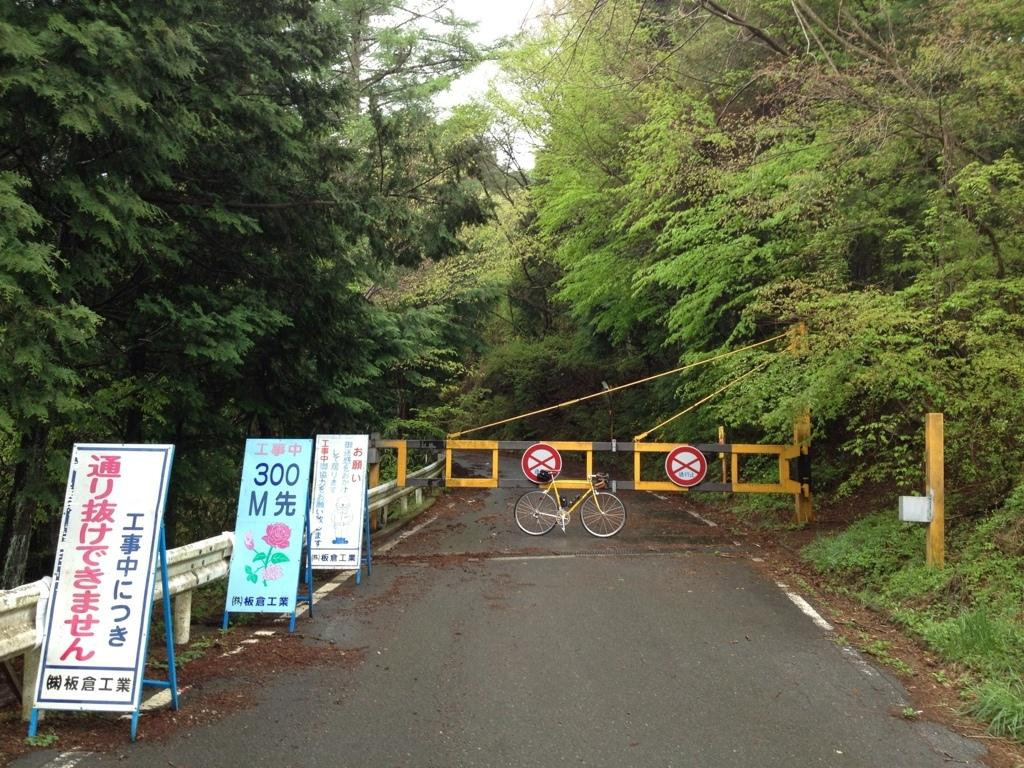What is located in the center of the image? There is a barrier, a bicycle, boards, and a road in the center of the image. What type of transportation can be seen in the image? There is a bicycle in the center of the image. What is the condition of the road in the image? The road is in the center of the image. What type of vegetation is present on both sides of the image? Trees are present on the left and right sides of the image. What is visible at the top of the image? The sky is visible at the top of the image. Can you tell me how many airports are depicted in the image? There are no airports present in the image. What type of coat is hanging on the trees on the left side of the image? There are no coats present in the image; only trees are visible on both sides. 